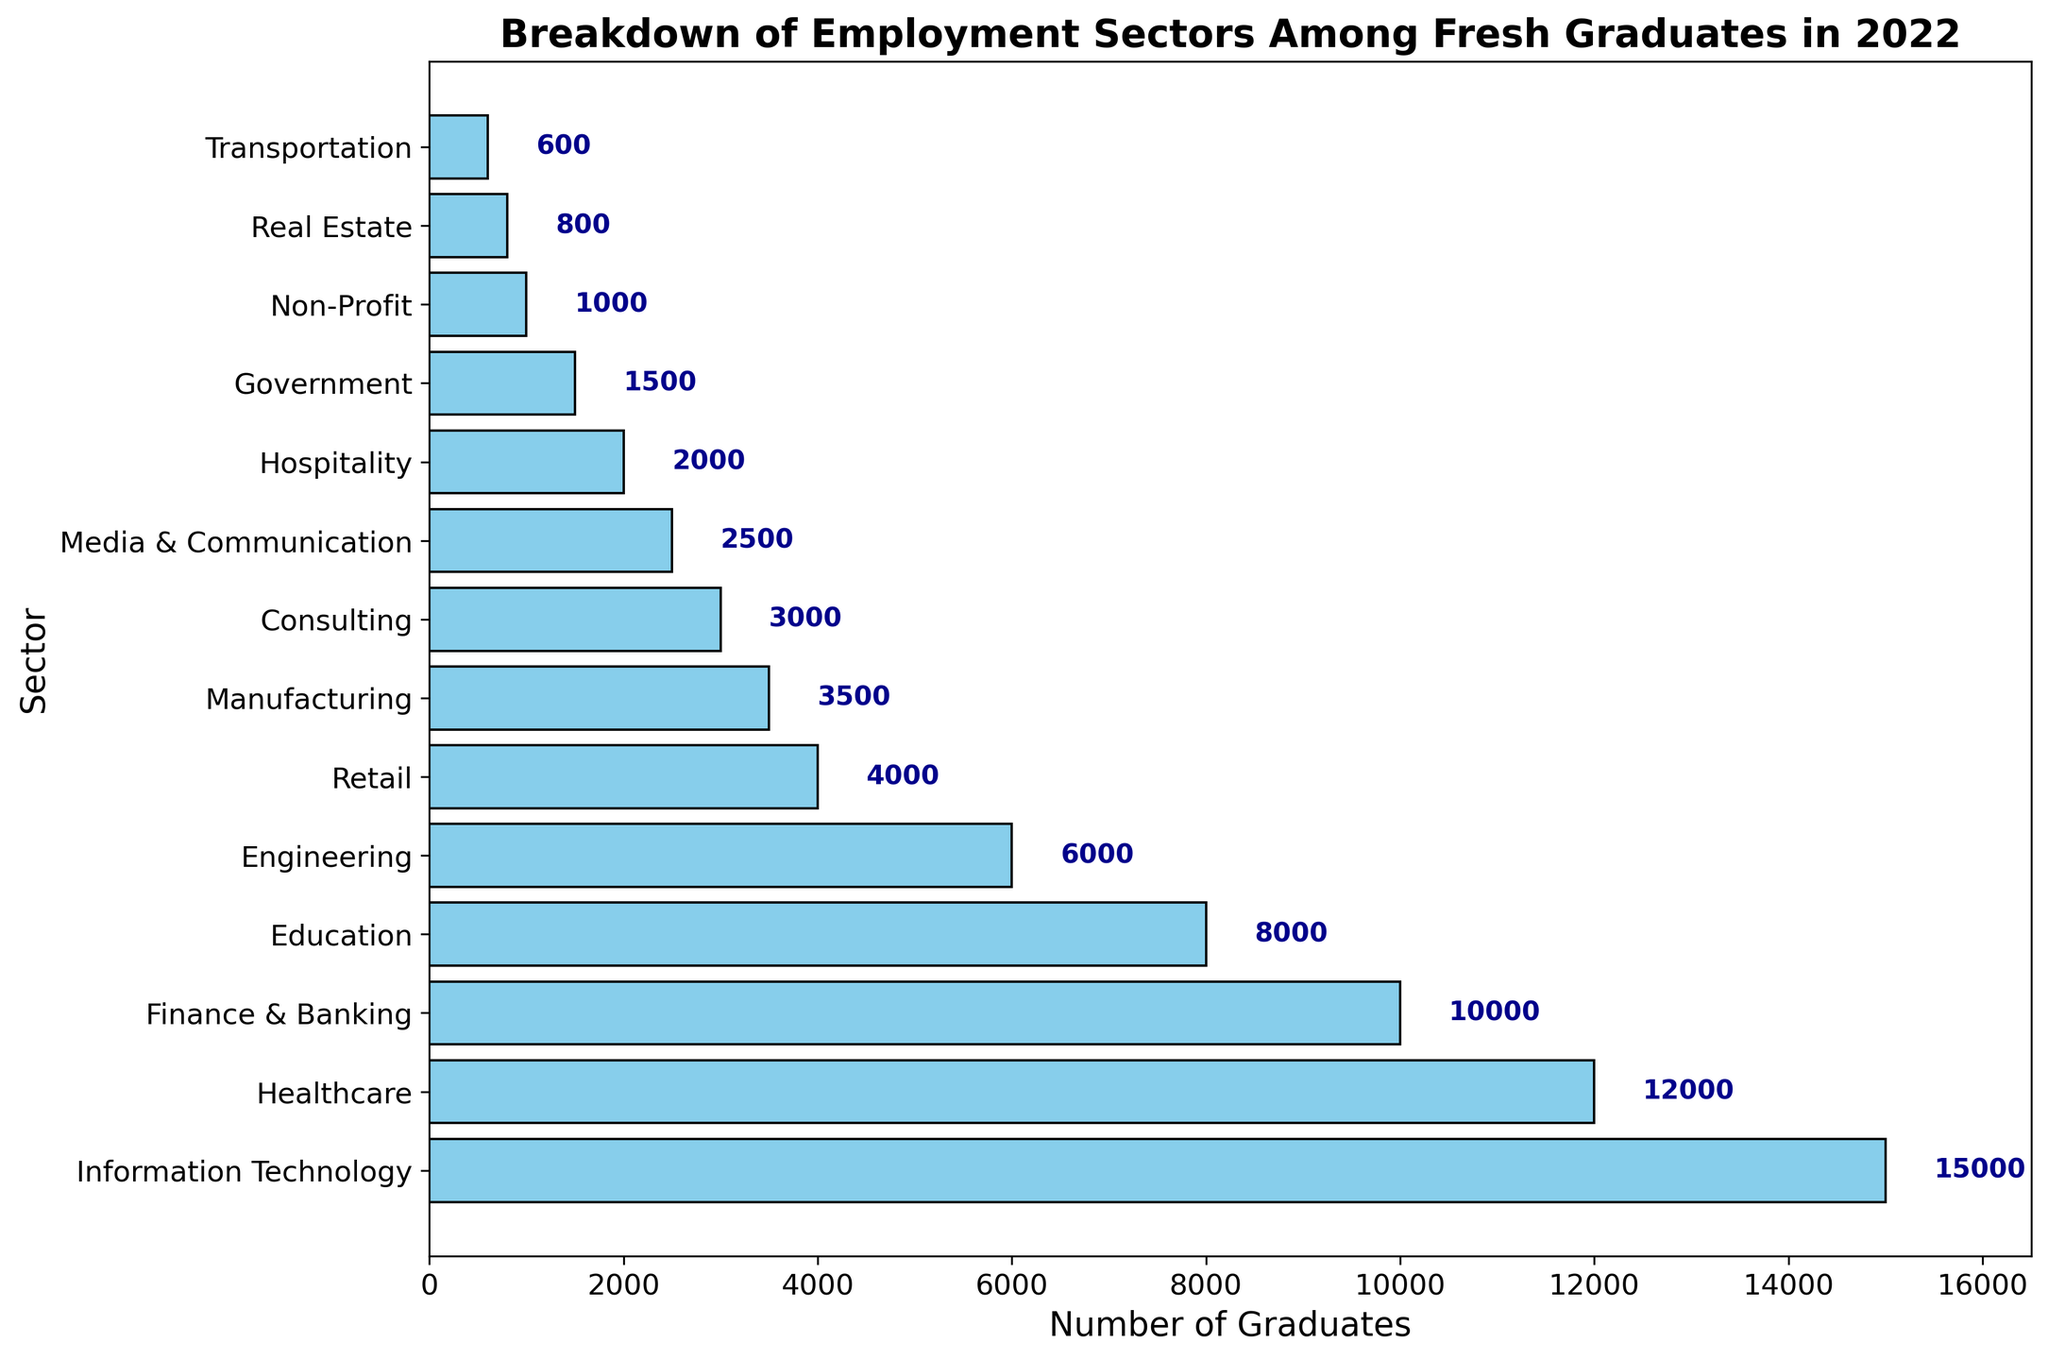Which sector has the highest number of graduates? To find the sector with the highest number of graduates, look for the longest bar in the chart. The Information Technology sector has the longest bar.
Answer: Information Technology Which sector has the least number of graduates? To determine the sector with the least number of graduates, look for the shortest bar in the chart. The Transportation sector has the shortest bar.
Answer: Transportation How many more graduates are in the Healthcare sector compared to the Education sector? First, locate and compare the sizes of the bars for the Healthcare and Education sectors. The Healthcare sector has 12,000 graduates and the Education sector has 8,000 graduates. The difference is 12,000 - 8,000 = 4,000.
Answer: 4,000 What is the combined number of graduates in Engineering and Media & Communication sectors? Add the number of graduates in the Engineering sector (6,000) and the Media & Communication sector (2,500). The combined number is 6,000 + 2,500 = 8,500.
Answer: 8,500 Which sector has fewer graduates, Finance & Banking or Retail? Compare the lengths of the bars for the Finance & Banking and Retail sectors. The Finance & Banking sector has 10,000 graduates, and the Retail sector has 4,000 graduates. Therefore, Retail has fewer graduates.
Answer: Retail What is the average number of graduates in the Government, Non-Profit, and Real Estate sectors? First, determine the number of graduates in each sector: Government (1,500), Non-Profit (1,000), and Real Estate (800). Sum these numbers and then divide by the count of sectors. (1,500 + 1,000 + 800) / 3 = 3,300 / 3 = 1,100.
Answer: 1,100 Which sector has twice as many graduates as Manufacturing? Identify the number of graduates in the Manufacturing sector (3,500) and then look for a sector with approximately twice that number. The Healthcare sector has 12,000 graduates, which is not twice but significantly higher. The closest is Finance & Banking with 10,000, not double but closer. No exact match found.
Answer: No exact match How many sectors have a number of graduates between 1,000 and 5,000? Count the sectors whose bars fall within the range of 1,000 to 5,000. The sectors are Retail (4,000), Manufacturing (3,500), Consulting (3,000), Media & Communication (2,500), Hospitality (2,000), Government (1,500), and Non-Profit (1,000). There are 7 such sectors.
Answer: 7 What is the difference in the number of graduates between the Information Technology and the Hospitality sectors? Find the number of graduates in both sectors: Information Technology (15,000) and Hospitality (2,000). The difference is 15,000 - 2,000 = 13,000.
Answer: 13,000 